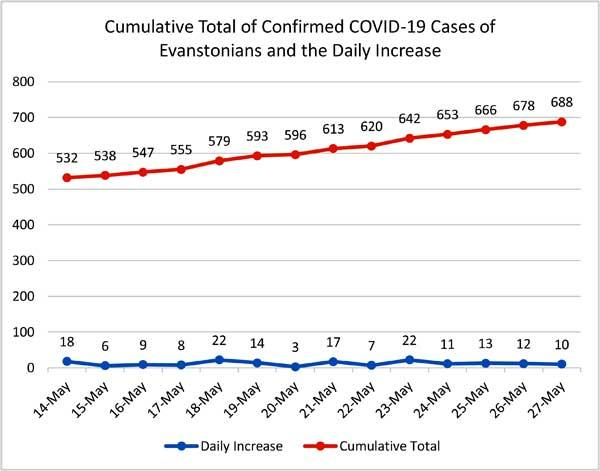Indicate a few pertinent items in this graphic. On the 24th and 25th of May, the total daily increase was obtained. On the 26th and 27th of May, the total daily increase was 22. The total daily increase and cumulative total on May 27th, including both values, is 698. 